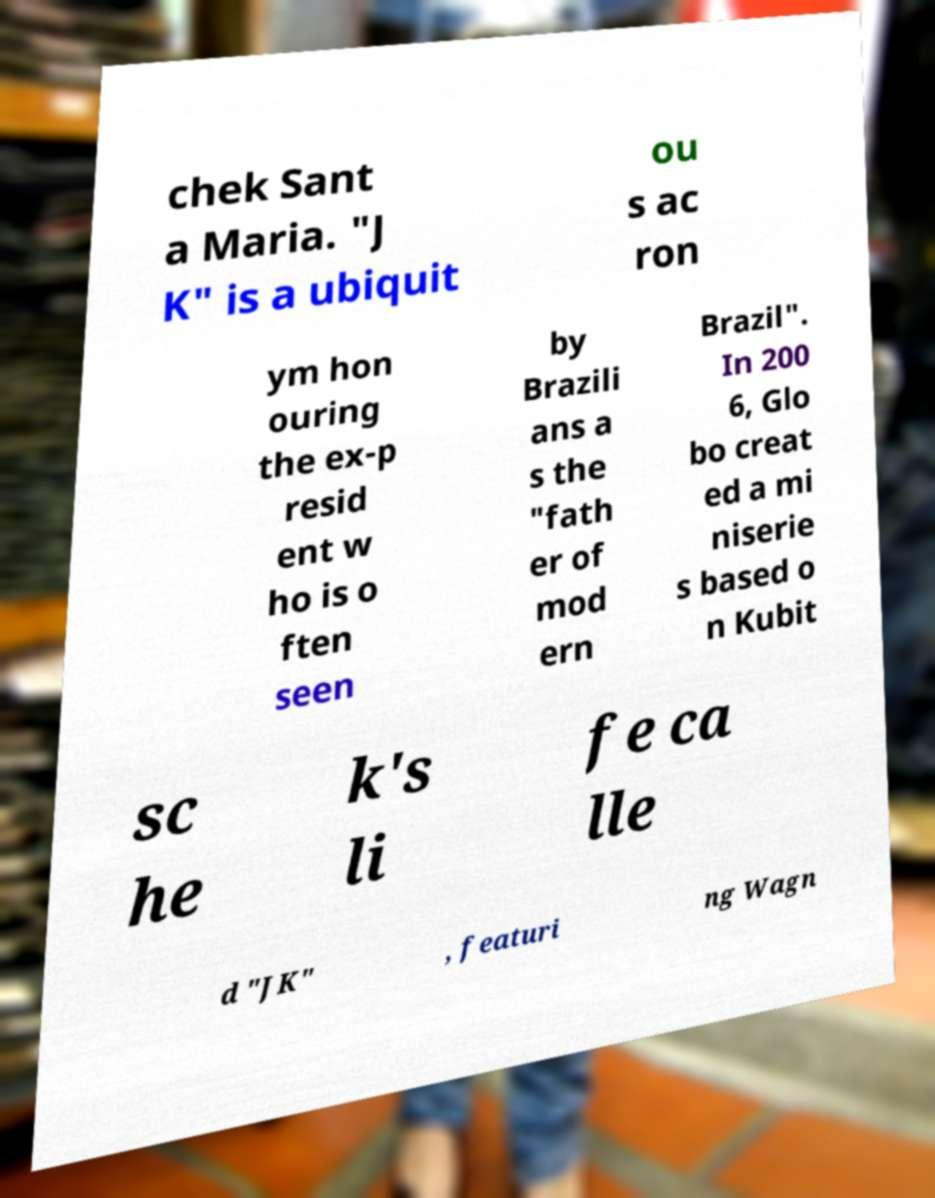Please identify and transcribe the text found in this image. chek Sant a Maria. "J K" is a ubiquit ou s ac ron ym hon ouring the ex-p resid ent w ho is o ften seen by Brazili ans a s the "fath er of mod ern Brazil". In 200 6, Glo bo creat ed a mi niserie s based o n Kubit sc he k's li fe ca lle d "JK" , featuri ng Wagn 